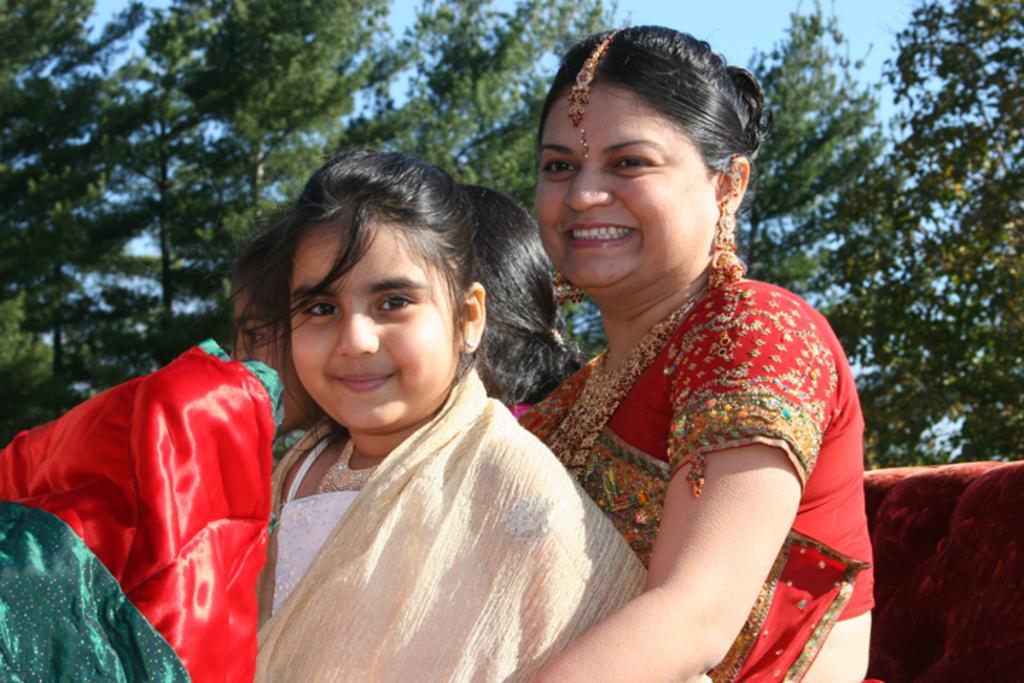Describe this image in one or two sentences. This image consists of three persons. A woman and two girls. In the background, there are trees. The woman is wearing red color saree. 